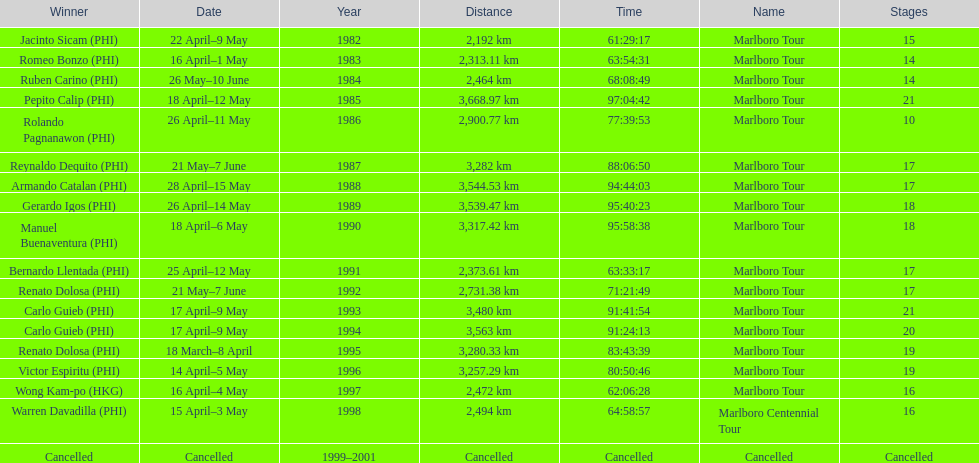What was the largest distance traveled for the marlboro tour? 3,668.97 km. 